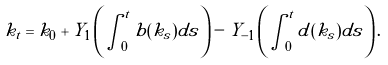<formula> <loc_0><loc_0><loc_500><loc_500>k _ { t } = k _ { 0 } + Y _ { 1 } \left ( \int _ { 0 } ^ { t } b ( k _ { s } ) d s \right ) - Y _ { - 1 } \left ( \int _ { 0 } ^ { t } d ( k _ { s } ) d s \right ) .</formula> 